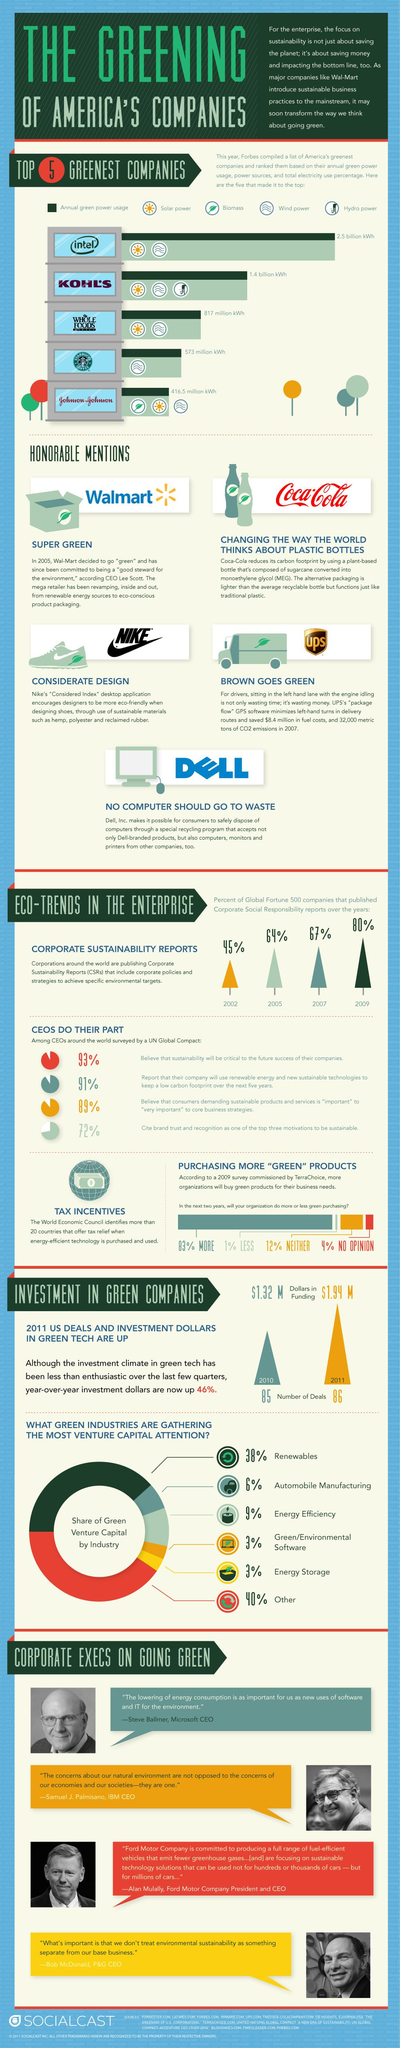Point out several critical features in this image. Starbucks Coffee is the company that uses green power derived from wind energy as its source. The green industry with the highest percentage of green capital is renewables. Johnson & Johnson is a company that uses biofuel to source its green power. Intel utilizes a variety of power sources, including solar and wind energy, to generate eco-friendly electricity. The percentage increase in companies' CSR initiatives from 2007 to 2009 was 13%. 